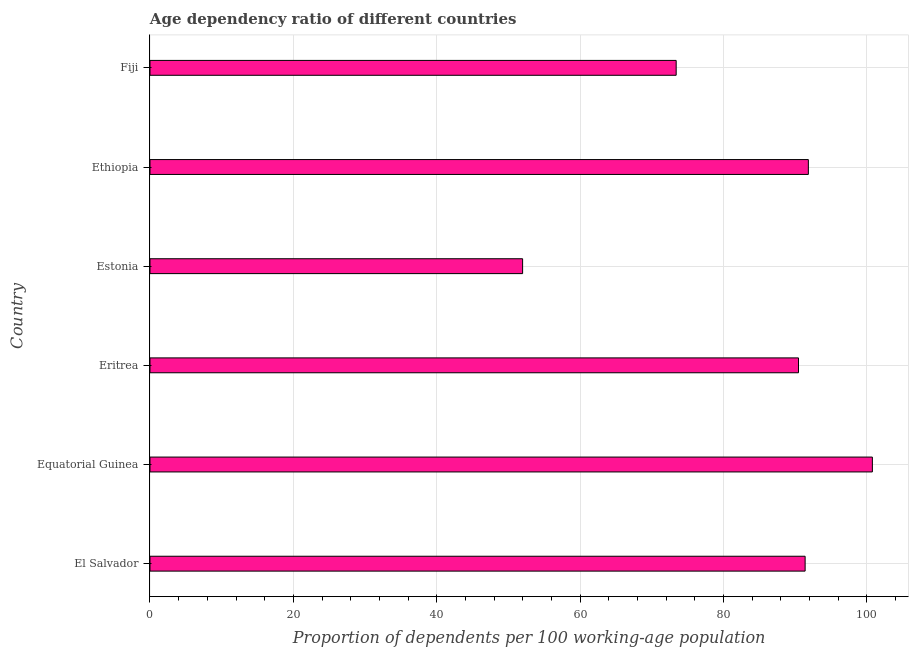Does the graph contain grids?
Offer a very short reply. Yes. What is the title of the graph?
Give a very brief answer. Age dependency ratio of different countries. What is the label or title of the X-axis?
Offer a very short reply. Proportion of dependents per 100 working-age population. What is the age dependency ratio in Ethiopia?
Make the answer very short. 91.84. Across all countries, what is the maximum age dependency ratio?
Keep it short and to the point. 100.77. Across all countries, what is the minimum age dependency ratio?
Offer a very short reply. 51.98. In which country was the age dependency ratio maximum?
Make the answer very short. Equatorial Guinea. In which country was the age dependency ratio minimum?
Your answer should be compact. Estonia. What is the sum of the age dependency ratio?
Provide a short and direct response. 499.83. What is the difference between the age dependency ratio in Estonia and Fiji?
Your answer should be compact. -21.42. What is the average age dependency ratio per country?
Ensure brevity in your answer.  83.31. What is the median age dependency ratio?
Your answer should be compact. 90.92. What is the ratio of the age dependency ratio in Ethiopia to that in Fiji?
Provide a short and direct response. 1.25. Is the age dependency ratio in El Salvador less than that in Equatorial Guinea?
Make the answer very short. Yes. What is the difference between the highest and the second highest age dependency ratio?
Your answer should be very brief. 8.93. What is the difference between the highest and the lowest age dependency ratio?
Give a very brief answer. 48.79. In how many countries, is the age dependency ratio greater than the average age dependency ratio taken over all countries?
Your response must be concise. 4. How many bars are there?
Make the answer very short. 6. What is the difference between two consecutive major ticks on the X-axis?
Your answer should be very brief. 20. Are the values on the major ticks of X-axis written in scientific E-notation?
Give a very brief answer. No. What is the Proportion of dependents per 100 working-age population of El Salvador?
Offer a terse response. 91.39. What is the Proportion of dependents per 100 working-age population of Equatorial Guinea?
Provide a succinct answer. 100.77. What is the Proportion of dependents per 100 working-age population in Eritrea?
Your answer should be very brief. 90.46. What is the Proportion of dependents per 100 working-age population of Estonia?
Your response must be concise. 51.98. What is the Proportion of dependents per 100 working-age population in Ethiopia?
Your answer should be compact. 91.84. What is the Proportion of dependents per 100 working-age population in Fiji?
Provide a succinct answer. 73.4. What is the difference between the Proportion of dependents per 100 working-age population in El Salvador and Equatorial Guinea?
Offer a very short reply. -9.38. What is the difference between the Proportion of dependents per 100 working-age population in El Salvador and Eritrea?
Your answer should be compact. 0.93. What is the difference between the Proportion of dependents per 100 working-age population in El Salvador and Estonia?
Ensure brevity in your answer.  39.41. What is the difference between the Proportion of dependents per 100 working-age population in El Salvador and Ethiopia?
Provide a short and direct response. -0.45. What is the difference between the Proportion of dependents per 100 working-age population in El Salvador and Fiji?
Provide a short and direct response. 17.99. What is the difference between the Proportion of dependents per 100 working-age population in Equatorial Guinea and Eritrea?
Offer a terse response. 10.31. What is the difference between the Proportion of dependents per 100 working-age population in Equatorial Guinea and Estonia?
Give a very brief answer. 48.79. What is the difference between the Proportion of dependents per 100 working-age population in Equatorial Guinea and Ethiopia?
Your response must be concise. 8.93. What is the difference between the Proportion of dependents per 100 working-age population in Equatorial Guinea and Fiji?
Your response must be concise. 27.37. What is the difference between the Proportion of dependents per 100 working-age population in Eritrea and Estonia?
Ensure brevity in your answer.  38.48. What is the difference between the Proportion of dependents per 100 working-age population in Eritrea and Ethiopia?
Offer a very short reply. -1.38. What is the difference between the Proportion of dependents per 100 working-age population in Eritrea and Fiji?
Provide a succinct answer. 17.06. What is the difference between the Proportion of dependents per 100 working-age population in Estonia and Ethiopia?
Your answer should be compact. -39.86. What is the difference between the Proportion of dependents per 100 working-age population in Estonia and Fiji?
Keep it short and to the point. -21.42. What is the difference between the Proportion of dependents per 100 working-age population in Ethiopia and Fiji?
Your answer should be very brief. 18.44. What is the ratio of the Proportion of dependents per 100 working-age population in El Salvador to that in Equatorial Guinea?
Your response must be concise. 0.91. What is the ratio of the Proportion of dependents per 100 working-age population in El Salvador to that in Estonia?
Your response must be concise. 1.76. What is the ratio of the Proportion of dependents per 100 working-age population in El Salvador to that in Ethiopia?
Keep it short and to the point. 0.99. What is the ratio of the Proportion of dependents per 100 working-age population in El Salvador to that in Fiji?
Ensure brevity in your answer.  1.25. What is the ratio of the Proportion of dependents per 100 working-age population in Equatorial Guinea to that in Eritrea?
Make the answer very short. 1.11. What is the ratio of the Proportion of dependents per 100 working-age population in Equatorial Guinea to that in Estonia?
Offer a very short reply. 1.94. What is the ratio of the Proportion of dependents per 100 working-age population in Equatorial Guinea to that in Ethiopia?
Ensure brevity in your answer.  1.1. What is the ratio of the Proportion of dependents per 100 working-age population in Equatorial Guinea to that in Fiji?
Your answer should be compact. 1.37. What is the ratio of the Proportion of dependents per 100 working-age population in Eritrea to that in Estonia?
Your answer should be compact. 1.74. What is the ratio of the Proportion of dependents per 100 working-age population in Eritrea to that in Ethiopia?
Your response must be concise. 0.98. What is the ratio of the Proportion of dependents per 100 working-age population in Eritrea to that in Fiji?
Ensure brevity in your answer.  1.23. What is the ratio of the Proportion of dependents per 100 working-age population in Estonia to that in Ethiopia?
Your response must be concise. 0.57. What is the ratio of the Proportion of dependents per 100 working-age population in Estonia to that in Fiji?
Your answer should be compact. 0.71. What is the ratio of the Proportion of dependents per 100 working-age population in Ethiopia to that in Fiji?
Keep it short and to the point. 1.25. 